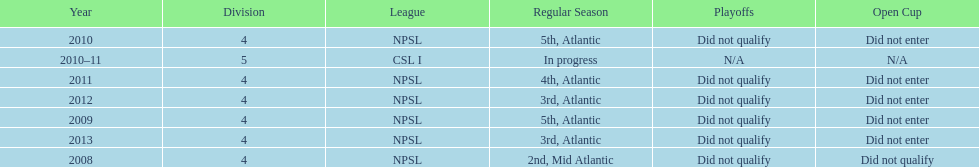What was the last year they came in 3rd place 2013. 